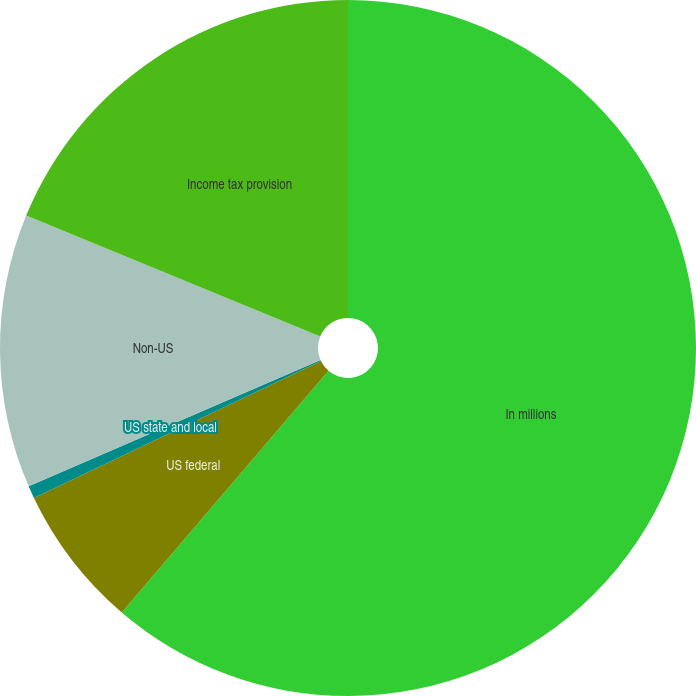<chart> <loc_0><loc_0><loc_500><loc_500><pie_chart><fcel>In millions<fcel>US federal<fcel>US state and local<fcel>Non-US<fcel>Income tax provision<nl><fcel>61.27%<fcel>6.65%<fcel>0.58%<fcel>12.72%<fcel>18.79%<nl></chart> 